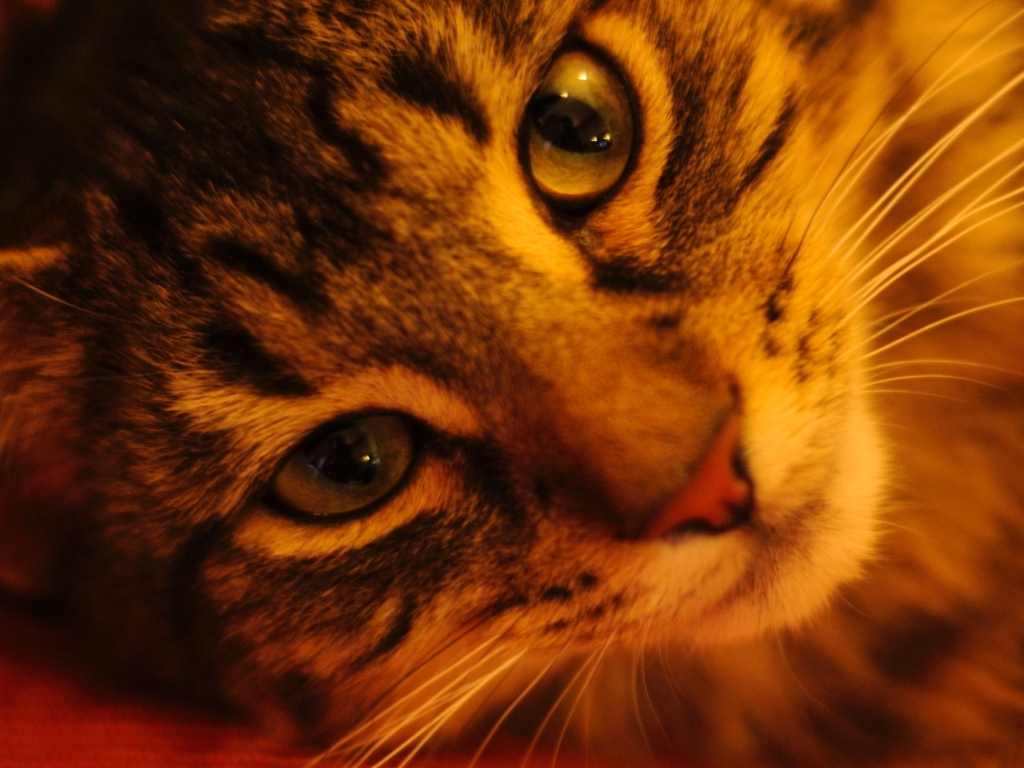Is the picture too blurry? The focus of the picture is on the cat's eyes, which are quite sharp. While there’s a soft blur surrounding the rest of the face and body, adding a dreamy quality to the image, it does not detract from the main subject. 